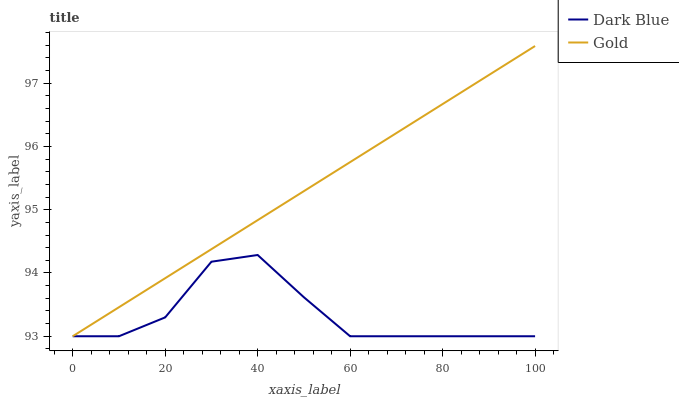Does Gold have the minimum area under the curve?
Answer yes or no. No. Is Gold the roughest?
Answer yes or no. No. 